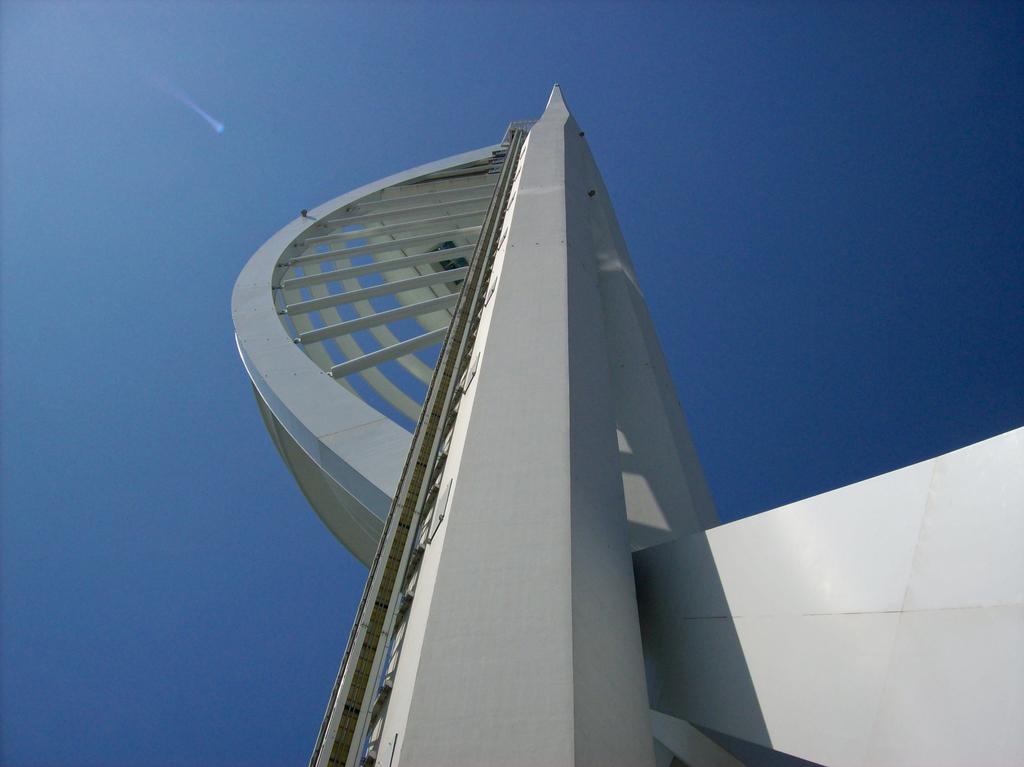Please provide a concise description of this image. In this image we can see an architecture. In the background there is sky. 